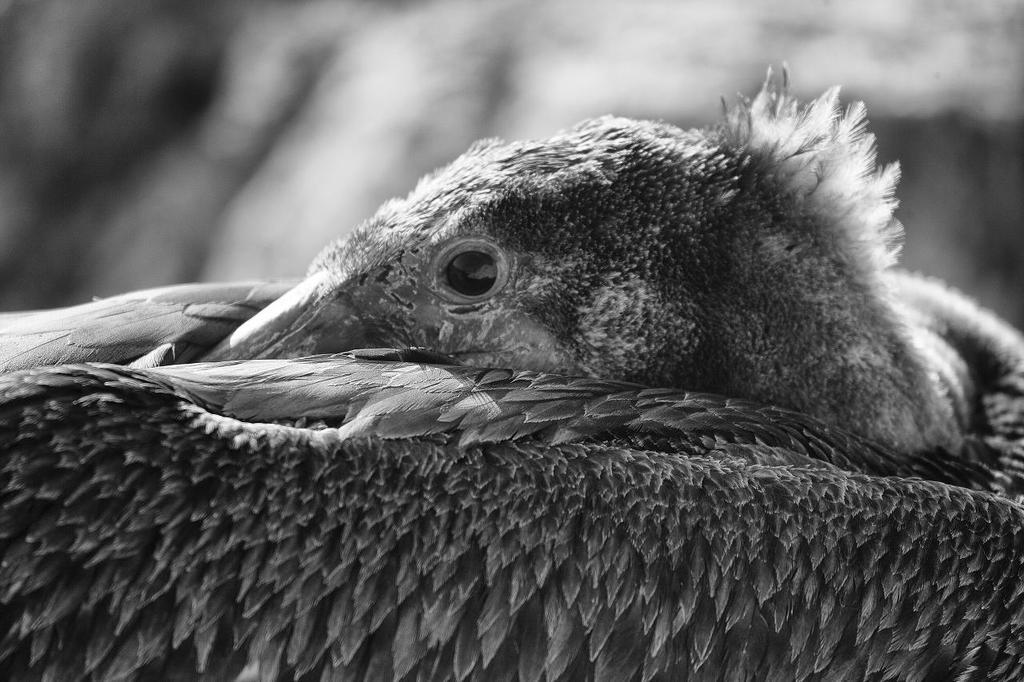What is the main subject in the foreground of the image? There is a bird in the foreground of the image. What is the bird doing in the image? The bird is covering its face with its wings. Can you describe the background of the image? The background of the image is blurred. How many people are joining the bird in the image? There are no people present in the image; it only features a bird. What type of chain is visible in the image? There is no chain present in the image. 